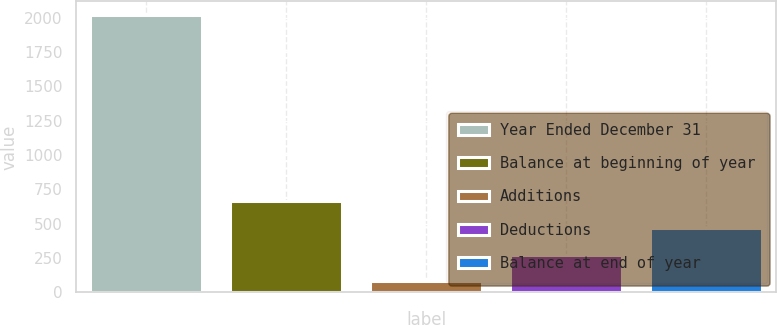<chart> <loc_0><loc_0><loc_500><loc_500><bar_chart><fcel>Year Ended December 31<fcel>Balance at beginning of year<fcel>Additions<fcel>Deductions<fcel>Balance at end of year<nl><fcel>2018<fcel>662.1<fcel>81<fcel>274.7<fcel>468.4<nl></chart> 